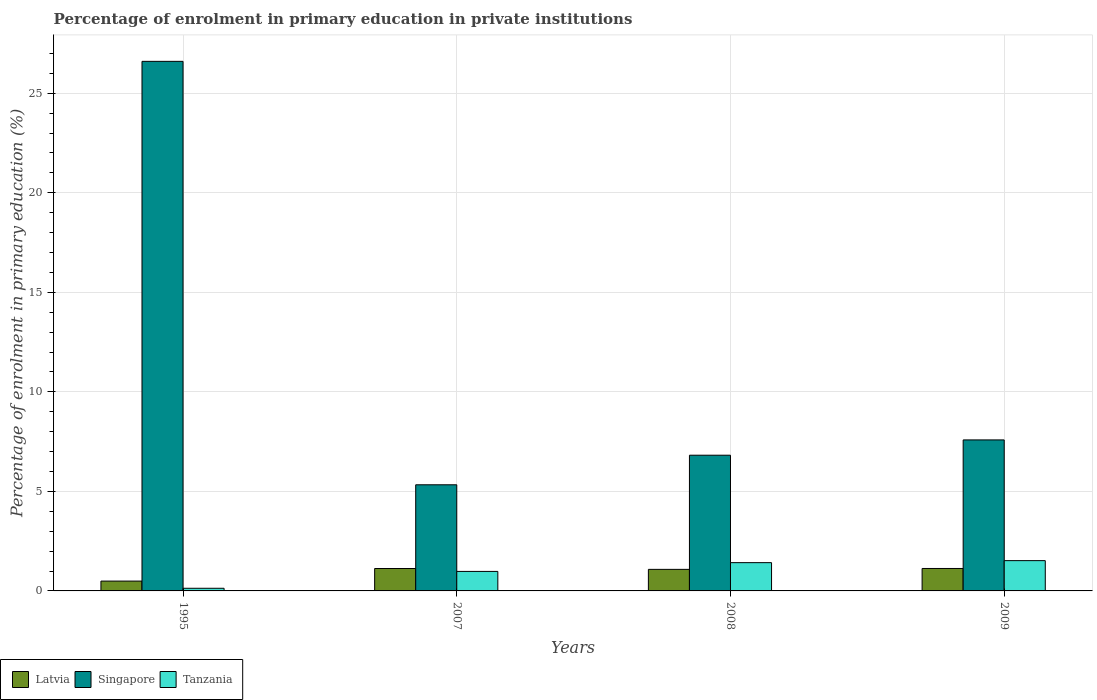In how many cases, is the number of bars for a given year not equal to the number of legend labels?
Offer a very short reply. 0. What is the percentage of enrolment in primary education in Latvia in 2007?
Provide a short and direct response. 1.13. Across all years, what is the maximum percentage of enrolment in primary education in Latvia?
Offer a terse response. 1.13. Across all years, what is the minimum percentage of enrolment in primary education in Tanzania?
Provide a short and direct response. 0.13. In which year was the percentage of enrolment in primary education in Singapore maximum?
Offer a very short reply. 1995. In which year was the percentage of enrolment in primary education in Latvia minimum?
Ensure brevity in your answer.  1995. What is the total percentage of enrolment in primary education in Singapore in the graph?
Ensure brevity in your answer.  46.34. What is the difference between the percentage of enrolment in primary education in Tanzania in 1995 and that in 2009?
Your response must be concise. -1.39. What is the difference between the percentage of enrolment in primary education in Singapore in 2007 and the percentage of enrolment in primary education in Latvia in 1995?
Offer a very short reply. 4.84. What is the average percentage of enrolment in primary education in Tanzania per year?
Provide a short and direct response. 1.01. In the year 2007, what is the difference between the percentage of enrolment in primary education in Tanzania and percentage of enrolment in primary education in Singapore?
Provide a short and direct response. -4.35. In how many years, is the percentage of enrolment in primary education in Singapore greater than 1 %?
Offer a terse response. 4. What is the ratio of the percentage of enrolment in primary education in Tanzania in 2008 to that in 2009?
Give a very brief answer. 0.93. Is the percentage of enrolment in primary education in Tanzania in 2008 less than that in 2009?
Keep it short and to the point. Yes. Is the difference between the percentage of enrolment in primary education in Tanzania in 2008 and 2009 greater than the difference between the percentage of enrolment in primary education in Singapore in 2008 and 2009?
Provide a succinct answer. Yes. What is the difference between the highest and the second highest percentage of enrolment in primary education in Singapore?
Ensure brevity in your answer.  19.02. What is the difference between the highest and the lowest percentage of enrolment in primary education in Tanzania?
Make the answer very short. 1.39. What does the 1st bar from the left in 2007 represents?
Give a very brief answer. Latvia. What does the 2nd bar from the right in 2009 represents?
Your answer should be very brief. Singapore. Is it the case that in every year, the sum of the percentage of enrolment in primary education in Singapore and percentage of enrolment in primary education in Latvia is greater than the percentage of enrolment in primary education in Tanzania?
Your answer should be very brief. Yes. How many bars are there?
Offer a very short reply. 12. Are all the bars in the graph horizontal?
Your answer should be compact. No. What is the difference between two consecutive major ticks on the Y-axis?
Provide a succinct answer. 5. Does the graph contain grids?
Keep it short and to the point. Yes. What is the title of the graph?
Ensure brevity in your answer.  Percentage of enrolment in primary education in private institutions. Does "European Union" appear as one of the legend labels in the graph?
Your answer should be compact. No. What is the label or title of the X-axis?
Ensure brevity in your answer.  Years. What is the label or title of the Y-axis?
Provide a succinct answer. Percentage of enrolment in primary education (%). What is the Percentage of enrolment in primary education (%) of Latvia in 1995?
Offer a terse response. 0.49. What is the Percentage of enrolment in primary education (%) of Singapore in 1995?
Your response must be concise. 26.6. What is the Percentage of enrolment in primary education (%) in Tanzania in 1995?
Offer a very short reply. 0.13. What is the Percentage of enrolment in primary education (%) of Latvia in 2007?
Your answer should be compact. 1.13. What is the Percentage of enrolment in primary education (%) in Singapore in 2007?
Offer a very short reply. 5.33. What is the Percentage of enrolment in primary education (%) in Tanzania in 2007?
Offer a very short reply. 0.98. What is the Percentage of enrolment in primary education (%) in Latvia in 2008?
Provide a succinct answer. 1.08. What is the Percentage of enrolment in primary education (%) in Singapore in 2008?
Offer a terse response. 6.82. What is the Percentage of enrolment in primary education (%) of Tanzania in 2008?
Your response must be concise. 1.42. What is the Percentage of enrolment in primary education (%) in Latvia in 2009?
Ensure brevity in your answer.  1.13. What is the Percentage of enrolment in primary education (%) in Singapore in 2009?
Provide a short and direct response. 7.59. What is the Percentage of enrolment in primary education (%) of Tanzania in 2009?
Ensure brevity in your answer.  1.52. Across all years, what is the maximum Percentage of enrolment in primary education (%) of Latvia?
Offer a very short reply. 1.13. Across all years, what is the maximum Percentage of enrolment in primary education (%) of Singapore?
Provide a succinct answer. 26.6. Across all years, what is the maximum Percentage of enrolment in primary education (%) of Tanzania?
Your response must be concise. 1.52. Across all years, what is the minimum Percentage of enrolment in primary education (%) of Latvia?
Make the answer very short. 0.49. Across all years, what is the minimum Percentage of enrolment in primary education (%) of Singapore?
Provide a succinct answer. 5.33. Across all years, what is the minimum Percentage of enrolment in primary education (%) in Tanzania?
Your answer should be compact. 0.13. What is the total Percentage of enrolment in primary education (%) of Latvia in the graph?
Keep it short and to the point. 3.83. What is the total Percentage of enrolment in primary education (%) in Singapore in the graph?
Offer a terse response. 46.34. What is the total Percentage of enrolment in primary education (%) in Tanzania in the graph?
Provide a succinct answer. 4.06. What is the difference between the Percentage of enrolment in primary education (%) of Latvia in 1995 and that in 2007?
Make the answer very short. -0.63. What is the difference between the Percentage of enrolment in primary education (%) in Singapore in 1995 and that in 2007?
Offer a very short reply. 21.27. What is the difference between the Percentage of enrolment in primary education (%) in Tanzania in 1995 and that in 2007?
Your answer should be compact. -0.85. What is the difference between the Percentage of enrolment in primary education (%) in Latvia in 1995 and that in 2008?
Your answer should be very brief. -0.59. What is the difference between the Percentage of enrolment in primary education (%) of Singapore in 1995 and that in 2008?
Ensure brevity in your answer.  19.79. What is the difference between the Percentage of enrolment in primary education (%) in Tanzania in 1995 and that in 2008?
Offer a terse response. -1.29. What is the difference between the Percentage of enrolment in primary education (%) in Latvia in 1995 and that in 2009?
Your answer should be very brief. -0.63. What is the difference between the Percentage of enrolment in primary education (%) in Singapore in 1995 and that in 2009?
Ensure brevity in your answer.  19.02. What is the difference between the Percentage of enrolment in primary education (%) of Tanzania in 1995 and that in 2009?
Provide a short and direct response. -1.39. What is the difference between the Percentage of enrolment in primary education (%) of Latvia in 2007 and that in 2008?
Your response must be concise. 0.04. What is the difference between the Percentage of enrolment in primary education (%) of Singapore in 2007 and that in 2008?
Your answer should be compact. -1.49. What is the difference between the Percentage of enrolment in primary education (%) in Tanzania in 2007 and that in 2008?
Provide a short and direct response. -0.44. What is the difference between the Percentage of enrolment in primary education (%) of Latvia in 2007 and that in 2009?
Ensure brevity in your answer.  -0. What is the difference between the Percentage of enrolment in primary education (%) in Singapore in 2007 and that in 2009?
Your response must be concise. -2.25. What is the difference between the Percentage of enrolment in primary education (%) in Tanzania in 2007 and that in 2009?
Provide a succinct answer. -0.54. What is the difference between the Percentage of enrolment in primary education (%) in Latvia in 2008 and that in 2009?
Give a very brief answer. -0.04. What is the difference between the Percentage of enrolment in primary education (%) in Singapore in 2008 and that in 2009?
Keep it short and to the point. -0.77. What is the difference between the Percentage of enrolment in primary education (%) of Tanzania in 2008 and that in 2009?
Offer a terse response. -0.1. What is the difference between the Percentage of enrolment in primary education (%) of Latvia in 1995 and the Percentage of enrolment in primary education (%) of Singapore in 2007?
Your answer should be compact. -4.84. What is the difference between the Percentage of enrolment in primary education (%) in Latvia in 1995 and the Percentage of enrolment in primary education (%) in Tanzania in 2007?
Keep it short and to the point. -0.49. What is the difference between the Percentage of enrolment in primary education (%) of Singapore in 1995 and the Percentage of enrolment in primary education (%) of Tanzania in 2007?
Ensure brevity in your answer.  25.62. What is the difference between the Percentage of enrolment in primary education (%) of Latvia in 1995 and the Percentage of enrolment in primary education (%) of Singapore in 2008?
Provide a succinct answer. -6.32. What is the difference between the Percentage of enrolment in primary education (%) in Latvia in 1995 and the Percentage of enrolment in primary education (%) in Tanzania in 2008?
Provide a short and direct response. -0.93. What is the difference between the Percentage of enrolment in primary education (%) of Singapore in 1995 and the Percentage of enrolment in primary education (%) of Tanzania in 2008?
Offer a very short reply. 25.18. What is the difference between the Percentage of enrolment in primary education (%) of Latvia in 1995 and the Percentage of enrolment in primary education (%) of Singapore in 2009?
Your answer should be compact. -7.09. What is the difference between the Percentage of enrolment in primary education (%) in Latvia in 1995 and the Percentage of enrolment in primary education (%) in Tanzania in 2009?
Your answer should be compact. -1.03. What is the difference between the Percentage of enrolment in primary education (%) of Singapore in 1995 and the Percentage of enrolment in primary education (%) of Tanzania in 2009?
Make the answer very short. 25.08. What is the difference between the Percentage of enrolment in primary education (%) in Latvia in 2007 and the Percentage of enrolment in primary education (%) in Singapore in 2008?
Make the answer very short. -5.69. What is the difference between the Percentage of enrolment in primary education (%) of Latvia in 2007 and the Percentage of enrolment in primary education (%) of Tanzania in 2008?
Your response must be concise. -0.29. What is the difference between the Percentage of enrolment in primary education (%) in Singapore in 2007 and the Percentage of enrolment in primary education (%) in Tanzania in 2008?
Your response must be concise. 3.91. What is the difference between the Percentage of enrolment in primary education (%) of Latvia in 2007 and the Percentage of enrolment in primary education (%) of Singapore in 2009?
Provide a short and direct response. -6.46. What is the difference between the Percentage of enrolment in primary education (%) in Latvia in 2007 and the Percentage of enrolment in primary education (%) in Tanzania in 2009?
Your answer should be very brief. -0.4. What is the difference between the Percentage of enrolment in primary education (%) of Singapore in 2007 and the Percentage of enrolment in primary education (%) of Tanzania in 2009?
Ensure brevity in your answer.  3.81. What is the difference between the Percentage of enrolment in primary education (%) of Latvia in 2008 and the Percentage of enrolment in primary education (%) of Singapore in 2009?
Offer a terse response. -6.5. What is the difference between the Percentage of enrolment in primary education (%) in Latvia in 2008 and the Percentage of enrolment in primary education (%) in Tanzania in 2009?
Your answer should be compact. -0.44. What is the difference between the Percentage of enrolment in primary education (%) of Singapore in 2008 and the Percentage of enrolment in primary education (%) of Tanzania in 2009?
Your response must be concise. 5.3. What is the average Percentage of enrolment in primary education (%) of Latvia per year?
Provide a succinct answer. 0.96. What is the average Percentage of enrolment in primary education (%) in Singapore per year?
Make the answer very short. 11.58. What is the average Percentage of enrolment in primary education (%) in Tanzania per year?
Keep it short and to the point. 1.01. In the year 1995, what is the difference between the Percentage of enrolment in primary education (%) of Latvia and Percentage of enrolment in primary education (%) of Singapore?
Make the answer very short. -26.11. In the year 1995, what is the difference between the Percentage of enrolment in primary education (%) in Latvia and Percentage of enrolment in primary education (%) in Tanzania?
Make the answer very short. 0.36. In the year 1995, what is the difference between the Percentage of enrolment in primary education (%) of Singapore and Percentage of enrolment in primary education (%) of Tanzania?
Provide a succinct answer. 26.47. In the year 2007, what is the difference between the Percentage of enrolment in primary education (%) of Latvia and Percentage of enrolment in primary education (%) of Singapore?
Your answer should be compact. -4.21. In the year 2007, what is the difference between the Percentage of enrolment in primary education (%) of Latvia and Percentage of enrolment in primary education (%) of Tanzania?
Provide a succinct answer. 0.15. In the year 2007, what is the difference between the Percentage of enrolment in primary education (%) in Singapore and Percentage of enrolment in primary education (%) in Tanzania?
Your response must be concise. 4.35. In the year 2008, what is the difference between the Percentage of enrolment in primary education (%) in Latvia and Percentage of enrolment in primary education (%) in Singapore?
Provide a short and direct response. -5.73. In the year 2008, what is the difference between the Percentage of enrolment in primary education (%) of Latvia and Percentage of enrolment in primary education (%) of Tanzania?
Offer a terse response. -0.34. In the year 2008, what is the difference between the Percentage of enrolment in primary education (%) in Singapore and Percentage of enrolment in primary education (%) in Tanzania?
Give a very brief answer. 5.4. In the year 2009, what is the difference between the Percentage of enrolment in primary education (%) of Latvia and Percentage of enrolment in primary education (%) of Singapore?
Keep it short and to the point. -6.46. In the year 2009, what is the difference between the Percentage of enrolment in primary education (%) of Latvia and Percentage of enrolment in primary education (%) of Tanzania?
Provide a succinct answer. -0.39. In the year 2009, what is the difference between the Percentage of enrolment in primary education (%) of Singapore and Percentage of enrolment in primary education (%) of Tanzania?
Your answer should be very brief. 6.06. What is the ratio of the Percentage of enrolment in primary education (%) in Latvia in 1995 to that in 2007?
Provide a short and direct response. 0.44. What is the ratio of the Percentage of enrolment in primary education (%) in Singapore in 1995 to that in 2007?
Your response must be concise. 4.99. What is the ratio of the Percentage of enrolment in primary education (%) of Tanzania in 1995 to that in 2007?
Your answer should be compact. 0.14. What is the ratio of the Percentage of enrolment in primary education (%) in Latvia in 1995 to that in 2008?
Your answer should be compact. 0.46. What is the ratio of the Percentage of enrolment in primary education (%) in Singapore in 1995 to that in 2008?
Offer a terse response. 3.9. What is the ratio of the Percentage of enrolment in primary education (%) of Tanzania in 1995 to that in 2008?
Provide a short and direct response. 0.09. What is the ratio of the Percentage of enrolment in primary education (%) of Latvia in 1995 to that in 2009?
Offer a very short reply. 0.44. What is the ratio of the Percentage of enrolment in primary education (%) of Singapore in 1995 to that in 2009?
Provide a succinct answer. 3.51. What is the ratio of the Percentage of enrolment in primary education (%) of Tanzania in 1995 to that in 2009?
Provide a succinct answer. 0.09. What is the ratio of the Percentage of enrolment in primary education (%) in Latvia in 2007 to that in 2008?
Keep it short and to the point. 1.04. What is the ratio of the Percentage of enrolment in primary education (%) of Singapore in 2007 to that in 2008?
Offer a terse response. 0.78. What is the ratio of the Percentage of enrolment in primary education (%) in Tanzania in 2007 to that in 2008?
Your answer should be compact. 0.69. What is the ratio of the Percentage of enrolment in primary education (%) of Latvia in 2007 to that in 2009?
Offer a terse response. 1. What is the ratio of the Percentage of enrolment in primary education (%) of Singapore in 2007 to that in 2009?
Your response must be concise. 0.7. What is the ratio of the Percentage of enrolment in primary education (%) of Tanzania in 2007 to that in 2009?
Ensure brevity in your answer.  0.64. What is the ratio of the Percentage of enrolment in primary education (%) in Latvia in 2008 to that in 2009?
Provide a short and direct response. 0.96. What is the ratio of the Percentage of enrolment in primary education (%) of Singapore in 2008 to that in 2009?
Provide a short and direct response. 0.9. What is the ratio of the Percentage of enrolment in primary education (%) in Tanzania in 2008 to that in 2009?
Provide a succinct answer. 0.93. What is the difference between the highest and the second highest Percentage of enrolment in primary education (%) in Latvia?
Offer a very short reply. 0. What is the difference between the highest and the second highest Percentage of enrolment in primary education (%) in Singapore?
Keep it short and to the point. 19.02. What is the difference between the highest and the second highest Percentage of enrolment in primary education (%) of Tanzania?
Make the answer very short. 0.1. What is the difference between the highest and the lowest Percentage of enrolment in primary education (%) of Latvia?
Ensure brevity in your answer.  0.63. What is the difference between the highest and the lowest Percentage of enrolment in primary education (%) in Singapore?
Offer a terse response. 21.27. What is the difference between the highest and the lowest Percentage of enrolment in primary education (%) of Tanzania?
Offer a very short reply. 1.39. 